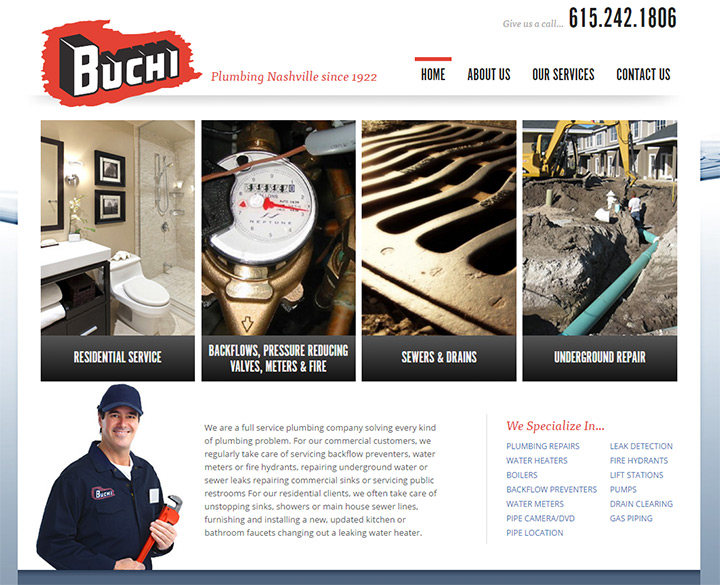How does the company's logo and slogan reflect its long-standing history and reputation? The company's logo and slogan, 'Plumbing Nashville since 1922,' prominently display their historical roots and long-standing commitment. The logo, with its bold and distinct design, projects a sense of reliability and trust that has been built over decades. The use of a vintage-inspired font combined with modern design elements bridges the past and present, reinforcing the company’s enduring presence and adaptation to contemporary standards. This fusion of historical reference and modern aesthetics in the branding effectively communicates the company's reputable legacy and its ongoing dedication to high-quality service. 